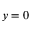<formula> <loc_0><loc_0><loc_500><loc_500>y = 0</formula> 